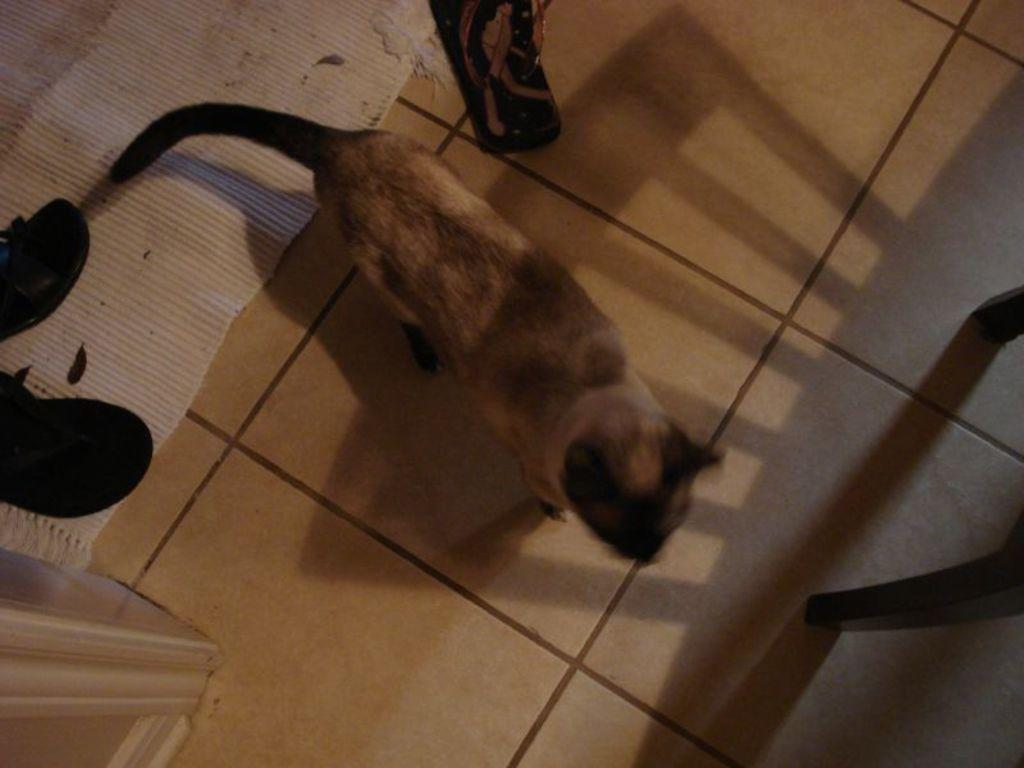What type of animal is in the image? There is an animal in the image, but the specific type cannot be determined from the provided facts. What material is present in the image? There is cloth in the image. What type of accessory is in the image? There is footwear in the image. Where are all the items located in the image? All items are on the floor. What is the aftermath of the ice drop in the image? There is no ice or drop present in the image, so there is no aftermath to discuss. 